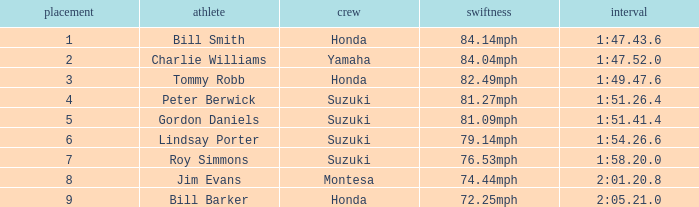What was the time for Peter Berwick of Team Suzuki? 1:51.26.4. 